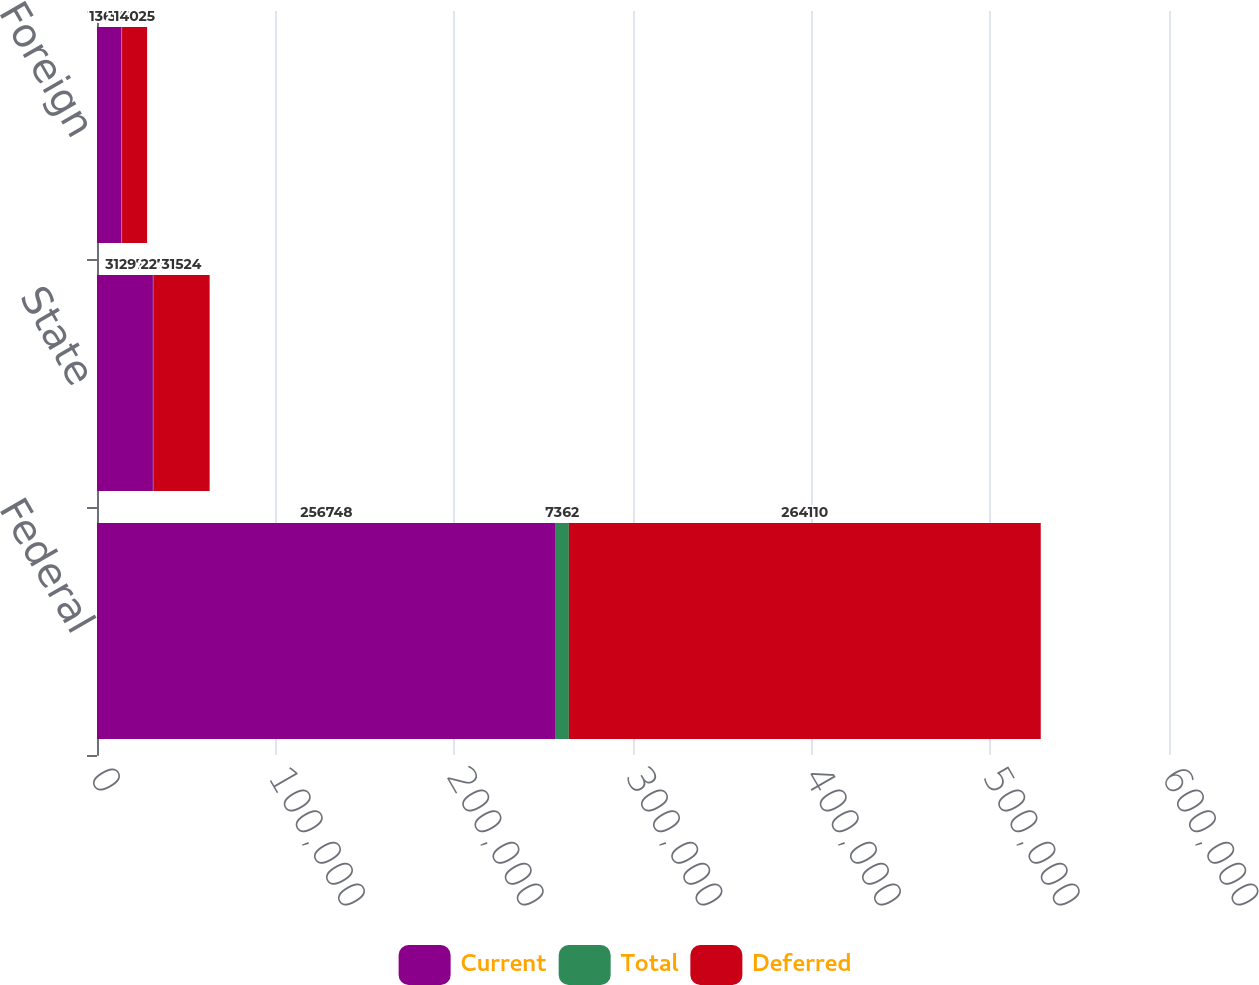Convert chart to OTSL. <chart><loc_0><loc_0><loc_500><loc_500><stacked_bar_chart><ecel><fcel>Federal<fcel>State<fcel>Foreign<nl><fcel>Current<fcel>256748<fcel>31297<fcel>13677<nl><fcel>Total<fcel>7362<fcel>227<fcel>348<nl><fcel>Deferred<fcel>264110<fcel>31524<fcel>14025<nl></chart> 